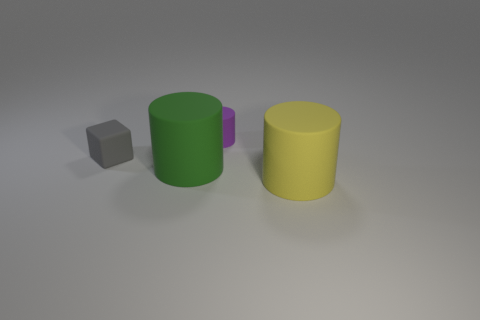Add 4 big blue blocks. How many objects exist? 8 Subtract all cylinders. How many objects are left? 1 Subtract all yellow cylinders. Subtract all cylinders. How many objects are left? 0 Add 1 large green rubber things. How many large green rubber things are left? 2 Add 4 big yellow objects. How many big yellow objects exist? 5 Subtract 0 blue blocks. How many objects are left? 4 